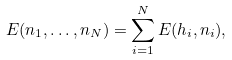<formula> <loc_0><loc_0><loc_500><loc_500>E ( n _ { 1 } , \dots , n _ { N } ) = \sum _ { i = 1 } ^ { N } E ( h _ { i } , n _ { i } ) ,</formula> 